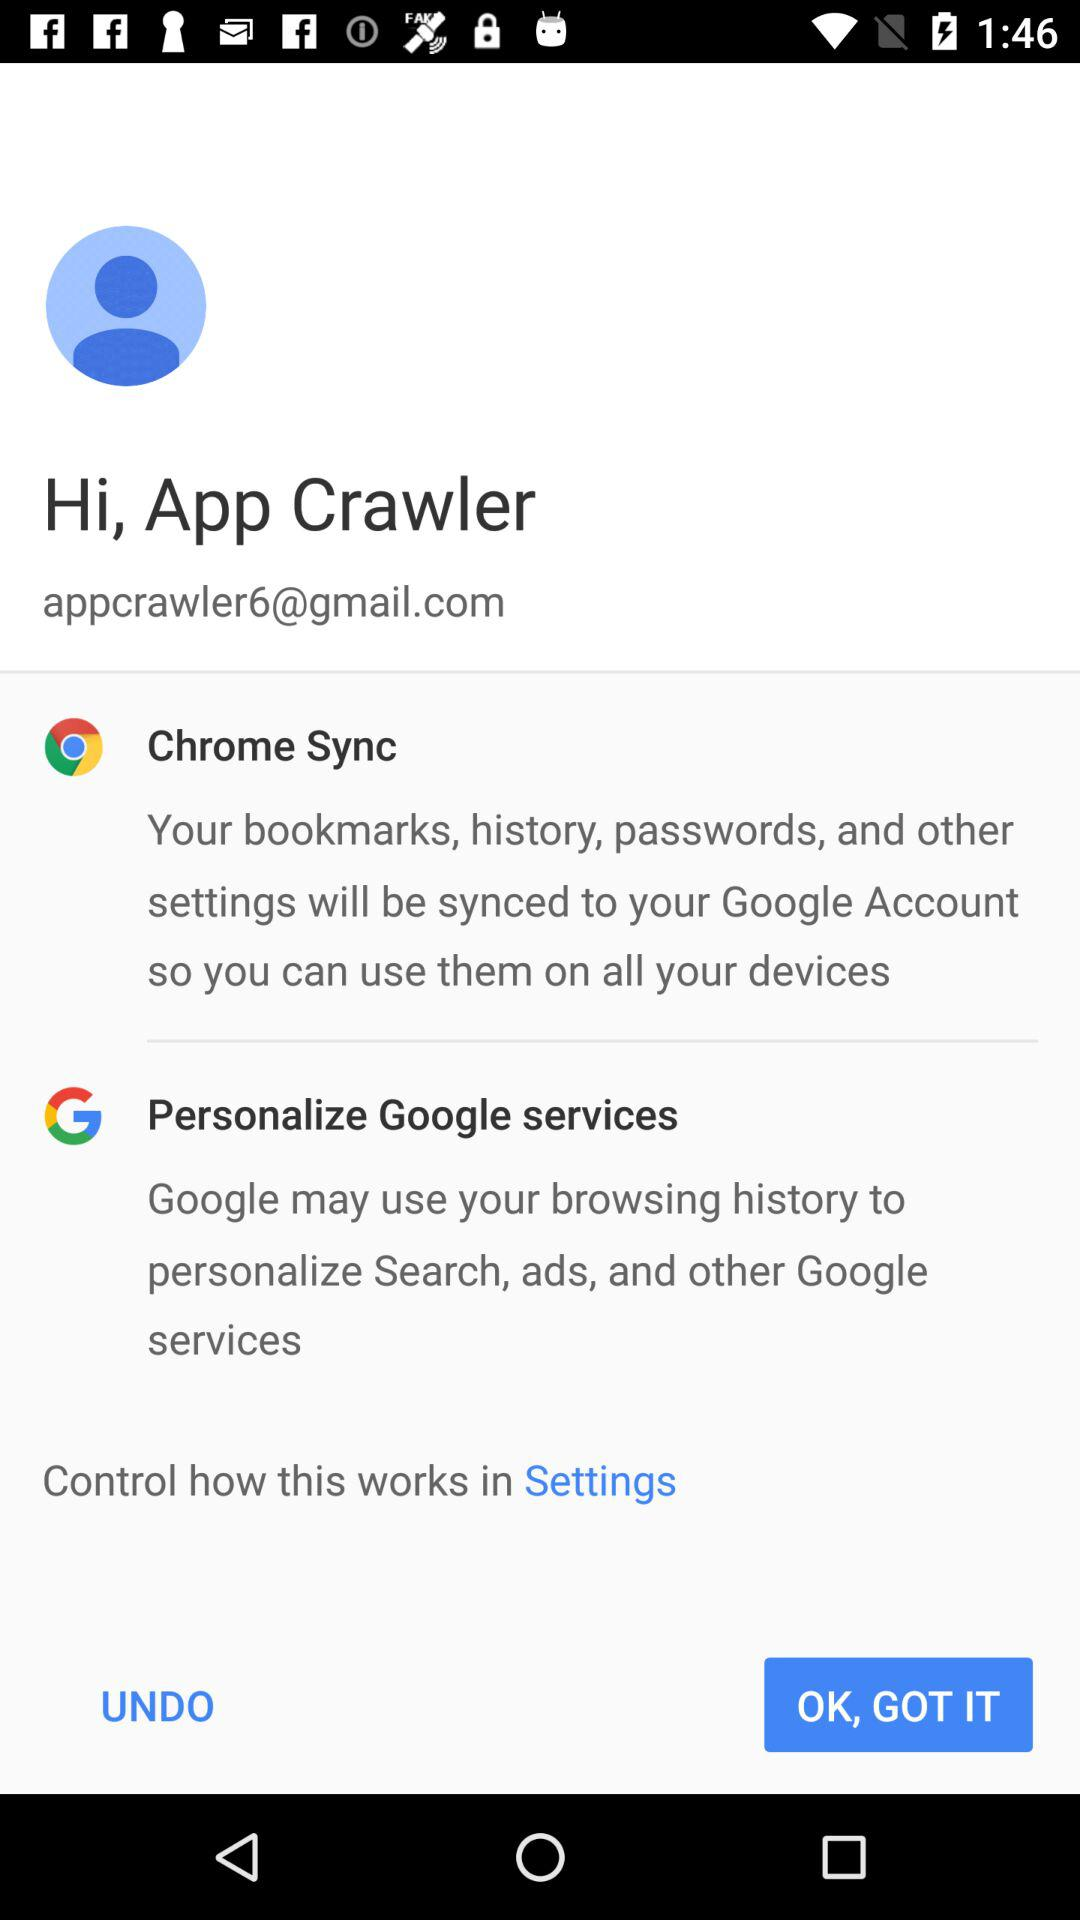What Chrome features will be synced with Google Account? The Chrome features that will be synced with the Google account are bookmarks, history, passwords and other settings. 